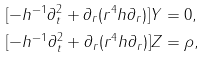Convert formula to latex. <formula><loc_0><loc_0><loc_500><loc_500>[ - h ^ { - 1 } \partial _ { t } ^ { 2 } + \partial _ { r } ( r ^ { 4 } h \partial _ { r } ) ] Y & = 0 , \\ [ - h ^ { - 1 } \partial _ { t } ^ { 2 } + \partial _ { r } ( r ^ { 4 } h \partial _ { r } ) ] Z & = \rho ,</formula> 